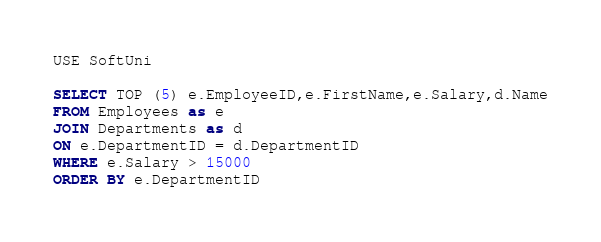Convert code to text. <code><loc_0><loc_0><loc_500><loc_500><_SQL_>USE SoftUni

SELECT TOP (5) e.EmployeeID,e.FirstName,e.Salary,d.Name
FROM Employees as e
JOIN Departments as d
ON e.DepartmentID = d.DepartmentID
WHERE e.Salary > 15000
ORDER BY e.DepartmentID</code> 